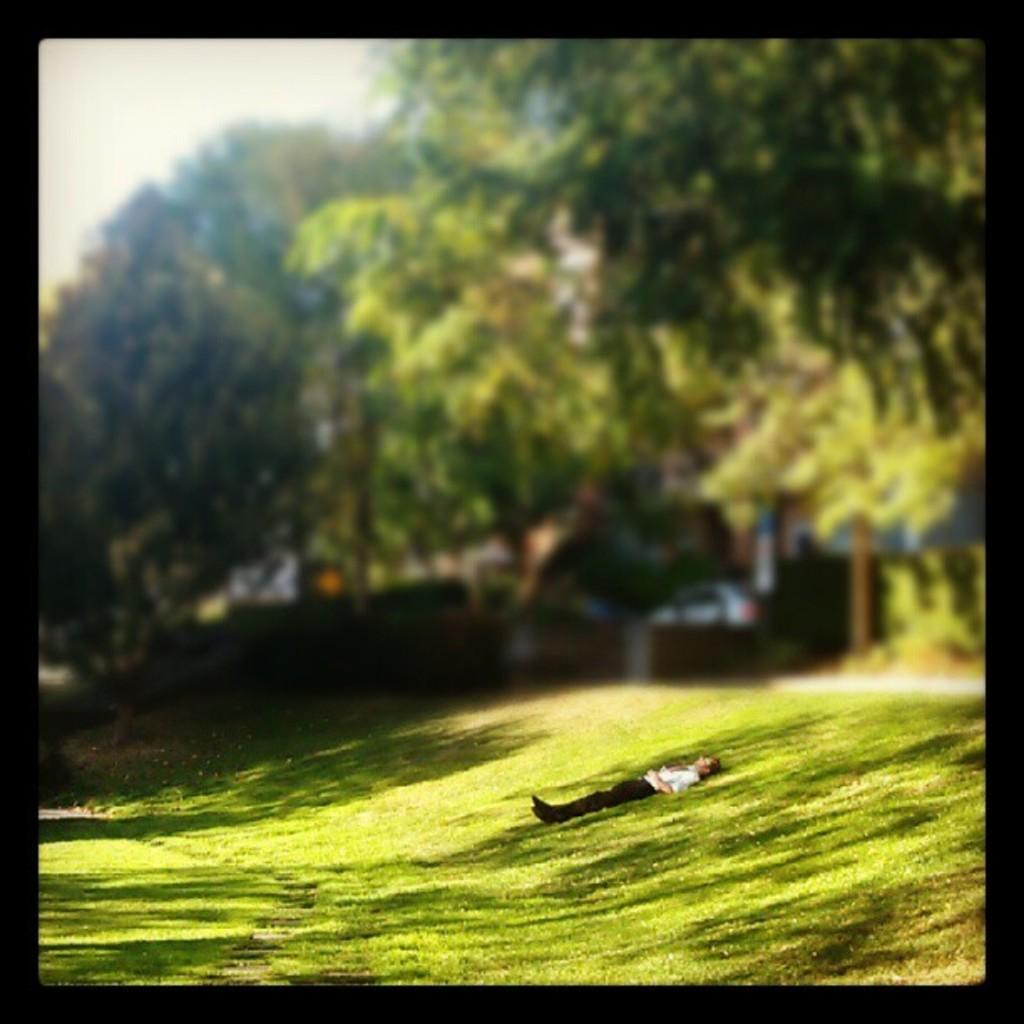What is the person in the image doing? The person is laying on the grass. What type of natural environment is visible in the image? There are trees in the image. Can you identify any man-made objects in the image? Yes, there appears to be a vehicle in the image. How much sugar is the person consuming while laying on the grass in the image? There is no indication of sugar consumption in the image, as it only shows a person laying on the grass and trees in the background. 